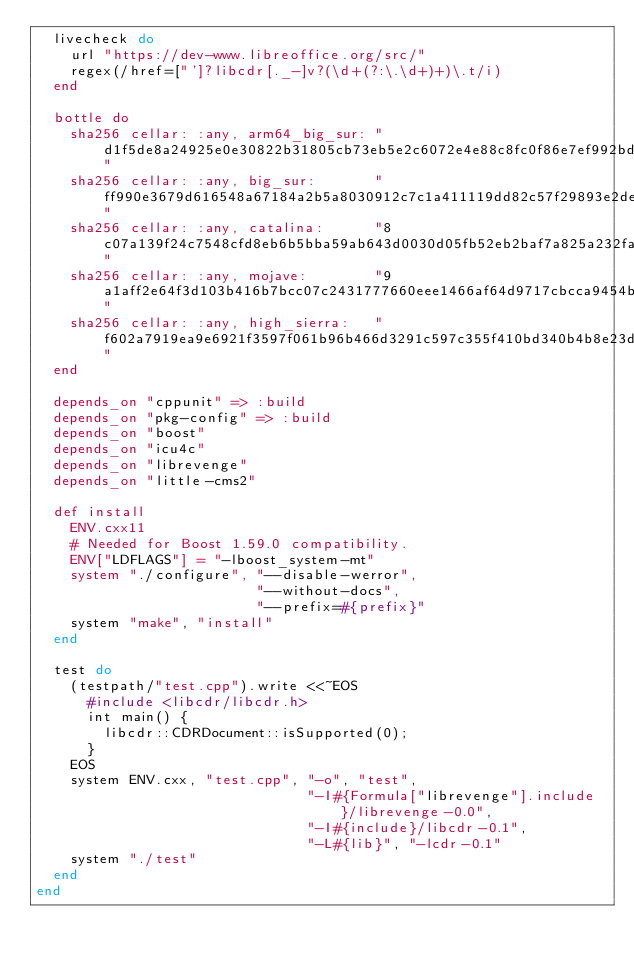Convert code to text. <code><loc_0><loc_0><loc_500><loc_500><_Ruby_>  livecheck do
    url "https://dev-www.libreoffice.org/src/"
    regex(/href=["']?libcdr[._-]v?(\d+(?:\.\d+)+)\.t/i)
  end

  bottle do
    sha256 cellar: :any, arm64_big_sur: "d1f5de8a24925e0e30822b31805cb73eb5e2c6072e4e88c8fc0f86e7ef992bdb"
    sha256 cellar: :any, big_sur:       "ff990e3679d616548a67184a2b5a8030912c7c1a411119dd82c57f29893e2dec"
    sha256 cellar: :any, catalina:      "8c07a139f24c7548cfd8eb6b5bba59ab643d0030d05fb52eb2baf7a825a232fa"
    sha256 cellar: :any, mojave:        "9a1aff2e64f3d103b416b7bcc07c2431777660eee1466af64d9717cbcca9454b"
    sha256 cellar: :any, high_sierra:   "f602a7919ea9e6921f3597f061b96b466d3291c597c355f410bd340b4b8e23d3"
  end

  depends_on "cppunit" => :build
  depends_on "pkg-config" => :build
  depends_on "boost"
  depends_on "icu4c"
  depends_on "librevenge"
  depends_on "little-cms2"

  def install
    ENV.cxx11
    # Needed for Boost 1.59.0 compatibility.
    ENV["LDFLAGS"] = "-lboost_system-mt"
    system "./configure", "--disable-werror",
                          "--without-docs",
                          "--prefix=#{prefix}"
    system "make", "install"
  end

  test do
    (testpath/"test.cpp").write <<~EOS
      #include <libcdr/libcdr.h>
      int main() {
        libcdr::CDRDocument::isSupported(0);
      }
    EOS
    system ENV.cxx, "test.cpp", "-o", "test",
                                "-I#{Formula["librevenge"].include}/librevenge-0.0",
                                "-I#{include}/libcdr-0.1",
                                "-L#{lib}", "-lcdr-0.1"
    system "./test"
  end
end
</code> 